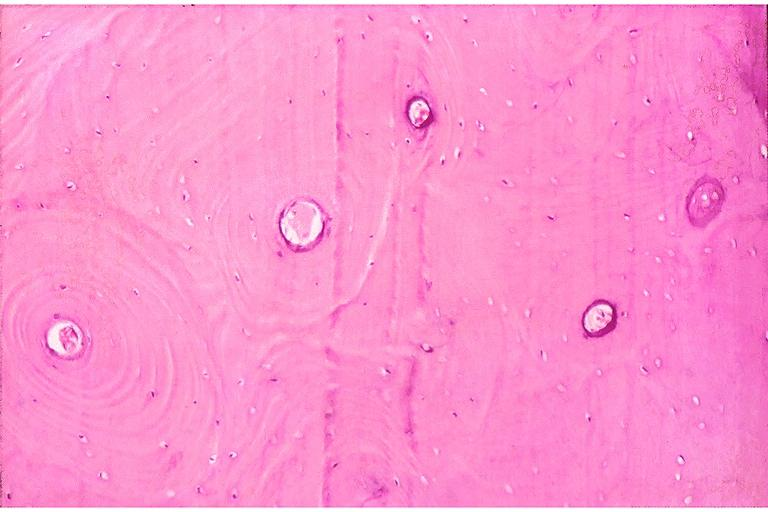what does this image show?
Answer the question using a single word or phrase. Dense sclerotic bone 